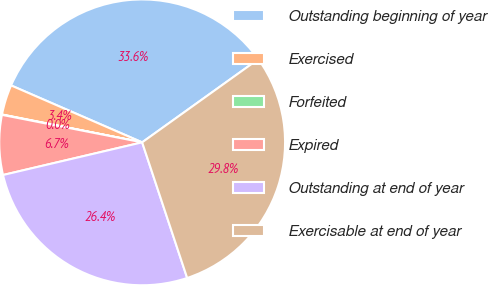Convert chart. <chart><loc_0><loc_0><loc_500><loc_500><pie_chart><fcel>Outstanding beginning of year<fcel>Exercised<fcel>Forfeited<fcel>Expired<fcel>Outstanding at end of year<fcel>Exercisable at end of year<nl><fcel>33.59%<fcel>3.4%<fcel>0.04%<fcel>6.75%<fcel>26.43%<fcel>29.79%<nl></chart> 